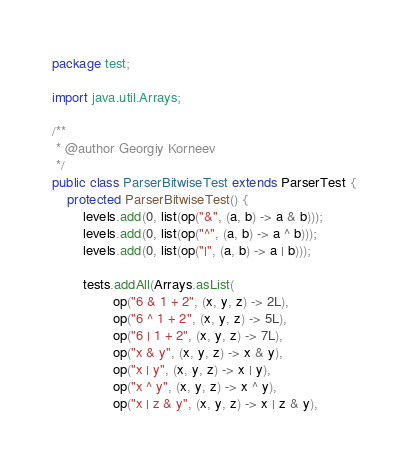<code> <loc_0><loc_0><loc_500><loc_500><_Java_>package test;

import java.util.Arrays;

/**
 * @author Georgiy Korneev
 */
public class ParserBitwiseTest extends ParserTest {
    protected ParserBitwiseTest() {
        levels.add(0, list(op("&", (a, b) -> a & b)));
        levels.add(0, list(op("^", (a, b) -> a ^ b)));
        levels.add(0, list(op("|", (a, b) -> a | b)));

        tests.addAll(Arrays.asList(
                op("6 & 1 + 2", (x, y, z) -> 2L),
                op("6 ^ 1 + 2", (x, y, z) -> 5L),
                op("6 | 1 + 2", (x, y, z) -> 7L),
                op("x & y", (x, y, z) -> x & y),
                op("x | y", (x, y, z) -> x | y),
                op("x ^ y", (x, y, z) -> x ^ y),
                op("x | z & y", (x, y, z) -> x | z & y),</code> 